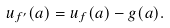<formula> <loc_0><loc_0><loc_500><loc_500>u _ { f ^ { \prime } } ( a ) = u _ { f } ( a ) - g ( a ) .</formula> 